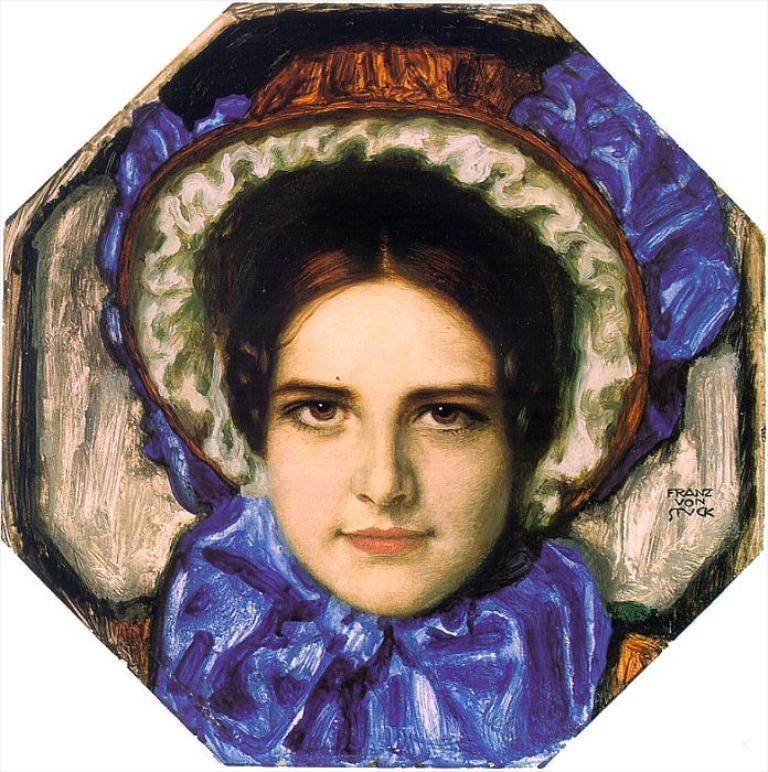In one or two sentences, can you explain what this image depicts? In this picture I can see a painting of a woman and there are letters on the painting. 